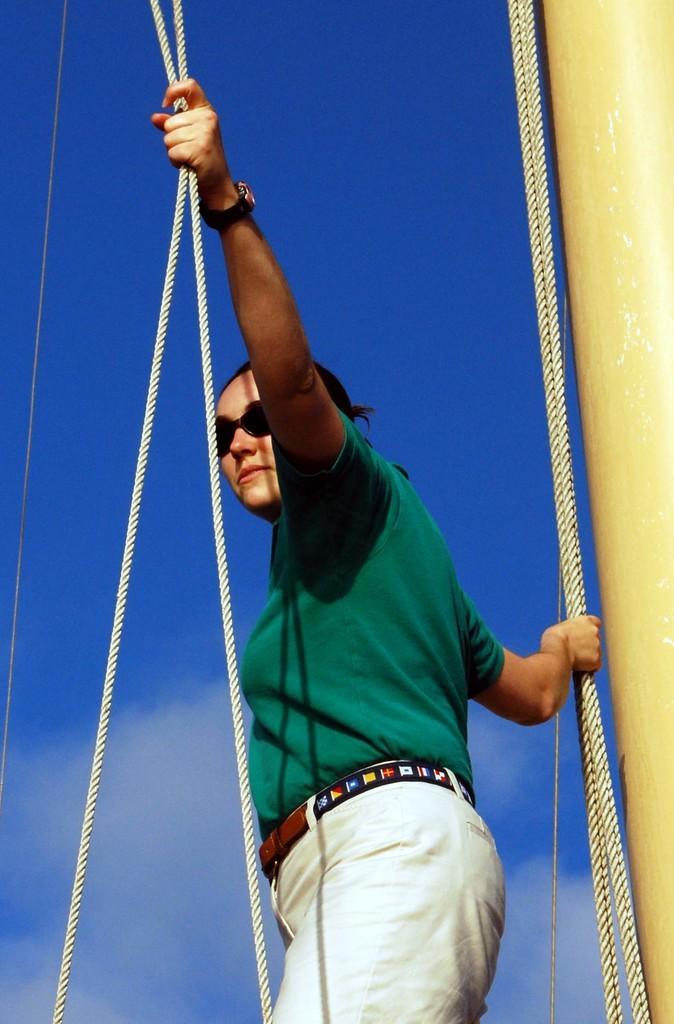Please provide a concise description of this image. In this picture I can see a woman standing and holding ropes, at the right corner of the image it looks like a pillar, and in the background there is sky. 